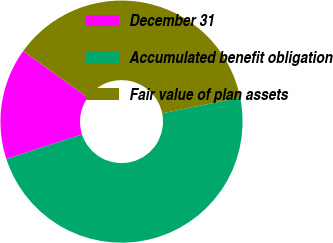Convert chart to OTSL. <chart><loc_0><loc_0><loc_500><loc_500><pie_chart><fcel>December 31<fcel>Accumulated benefit obligation<fcel>Fair value of plan assets<nl><fcel>14.9%<fcel>48.19%<fcel>36.91%<nl></chart> 